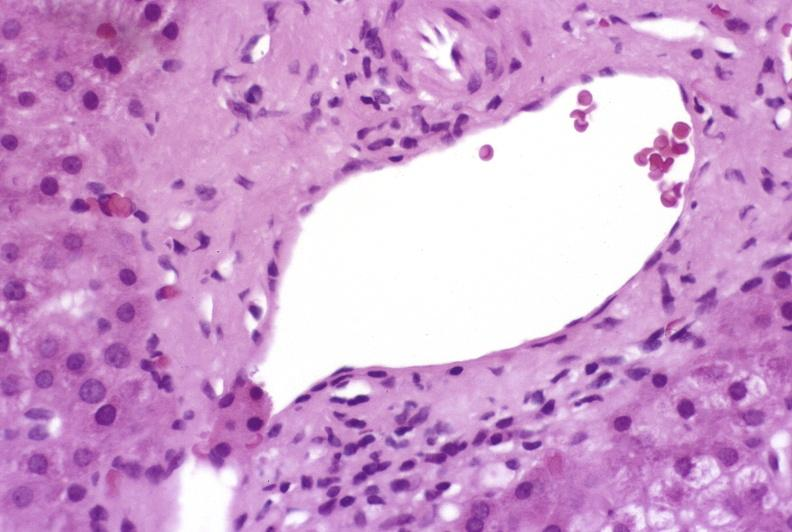what is present?
Answer the question using a single word or phrase. Hepatobiliary 